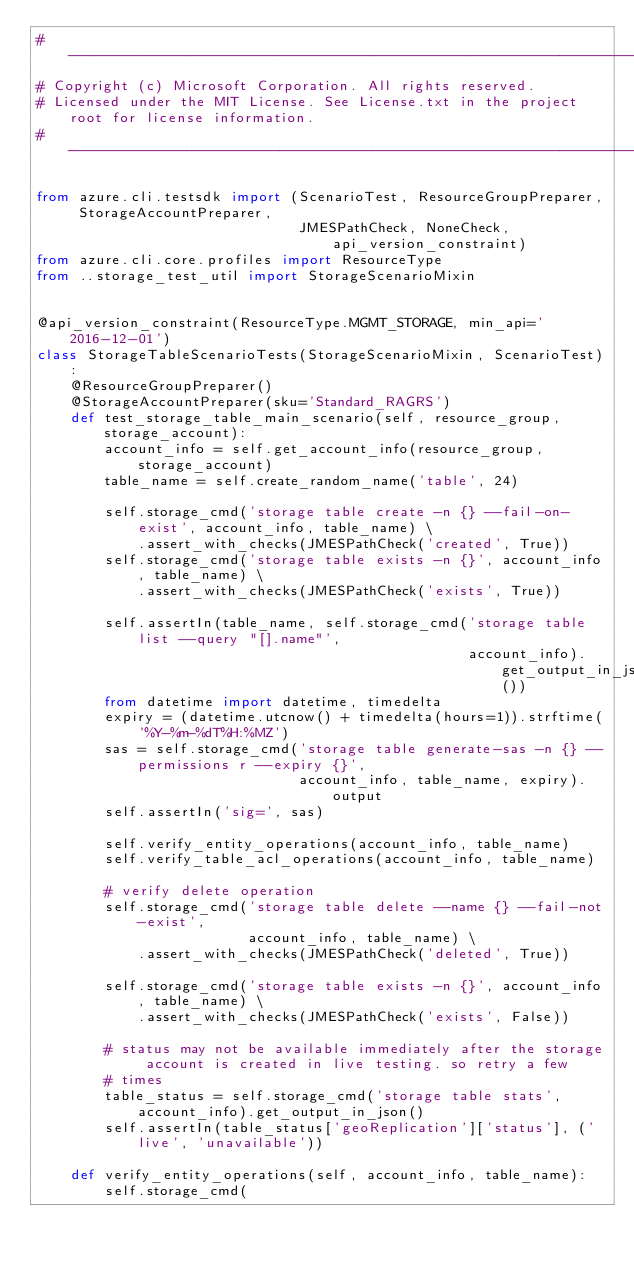<code> <loc_0><loc_0><loc_500><loc_500><_Python_># --------------------------------------------------------------------------------------------
# Copyright (c) Microsoft Corporation. All rights reserved.
# Licensed under the MIT License. See License.txt in the project root for license information.
# --------------------------------------------------------------------------------------------

from azure.cli.testsdk import (ScenarioTest, ResourceGroupPreparer, StorageAccountPreparer,
                               JMESPathCheck, NoneCheck, api_version_constraint)
from azure.cli.core.profiles import ResourceType
from ..storage_test_util import StorageScenarioMixin


@api_version_constraint(ResourceType.MGMT_STORAGE, min_api='2016-12-01')
class StorageTableScenarioTests(StorageScenarioMixin, ScenarioTest):
    @ResourceGroupPreparer()
    @StorageAccountPreparer(sku='Standard_RAGRS')
    def test_storage_table_main_scenario(self, resource_group, storage_account):
        account_info = self.get_account_info(resource_group, storage_account)
        table_name = self.create_random_name('table', 24)

        self.storage_cmd('storage table create -n {} --fail-on-exist', account_info, table_name) \
            .assert_with_checks(JMESPathCheck('created', True))
        self.storage_cmd('storage table exists -n {}', account_info, table_name) \
            .assert_with_checks(JMESPathCheck('exists', True))

        self.assertIn(table_name, self.storage_cmd('storage table list --query "[].name"',
                                                   account_info).get_output_in_json())
        from datetime import datetime, timedelta
        expiry = (datetime.utcnow() + timedelta(hours=1)).strftime('%Y-%m-%dT%H:%MZ')
        sas = self.storage_cmd('storage table generate-sas -n {} --permissions r --expiry {}',
                               account_info, table_name, expiry).output
        self.assertIn('sig=', sas)

        self.verify_entity_operations(account_info, table_name)
        self.verify_table_acl_operations(account_info, table_name)

        # verify delete operation
        self.storage_cmd('storage table delete --name {} --fail-not-exist',
                         account_info, table_name) \
            .assert_with_checks(JMESPathCheck('deleted', True))

        self.storage_cmd('storage table exists -n {}', account_info, table_name) \
            .assert_with_checks(JMESPathCheck('exists', False))

        # status may not be available immediately after the storage account is created in live testing. so retry a few
        # times
        table_status = self.storage_cmd('storage table stats', account_info).get_output_in_json()
        self.assertIn(table_status['geoReplication']['status'], ('live', 'unavailable'))

    def verify_entity_operations(self, account_info, table_name):
        self.storage_cmd(</code> 